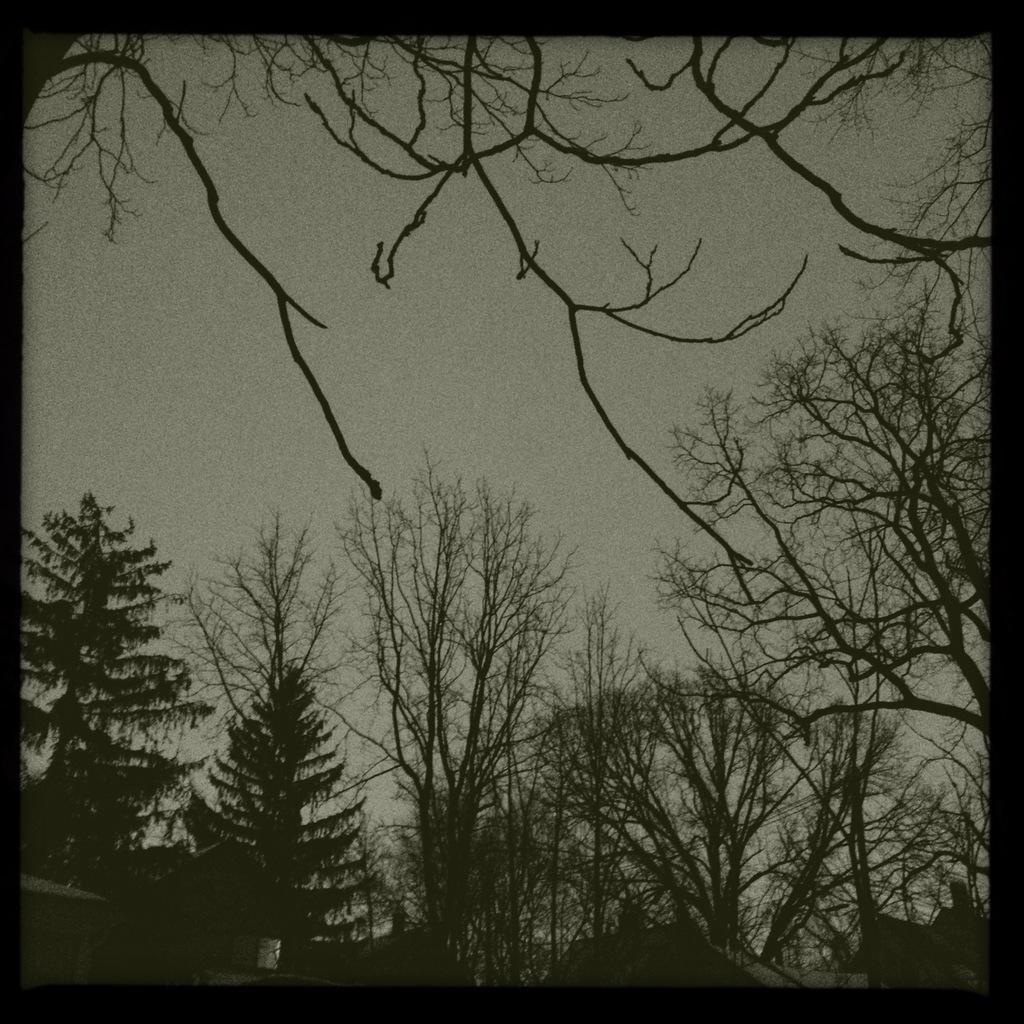Can you describe this image briefly? This is a black and white image. In this image we can see some houses with roof, a group of trees and the sky. 